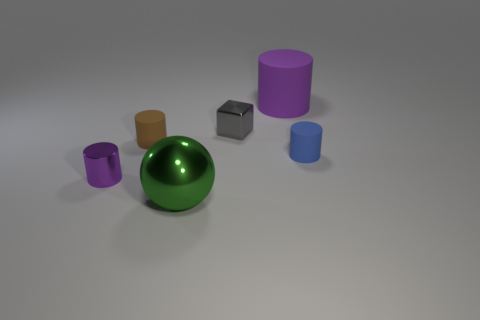What number of purple objects are spheres or big cylinders? In the image, there is one purple object that is a big cylinder. There are no purple spheres present. 